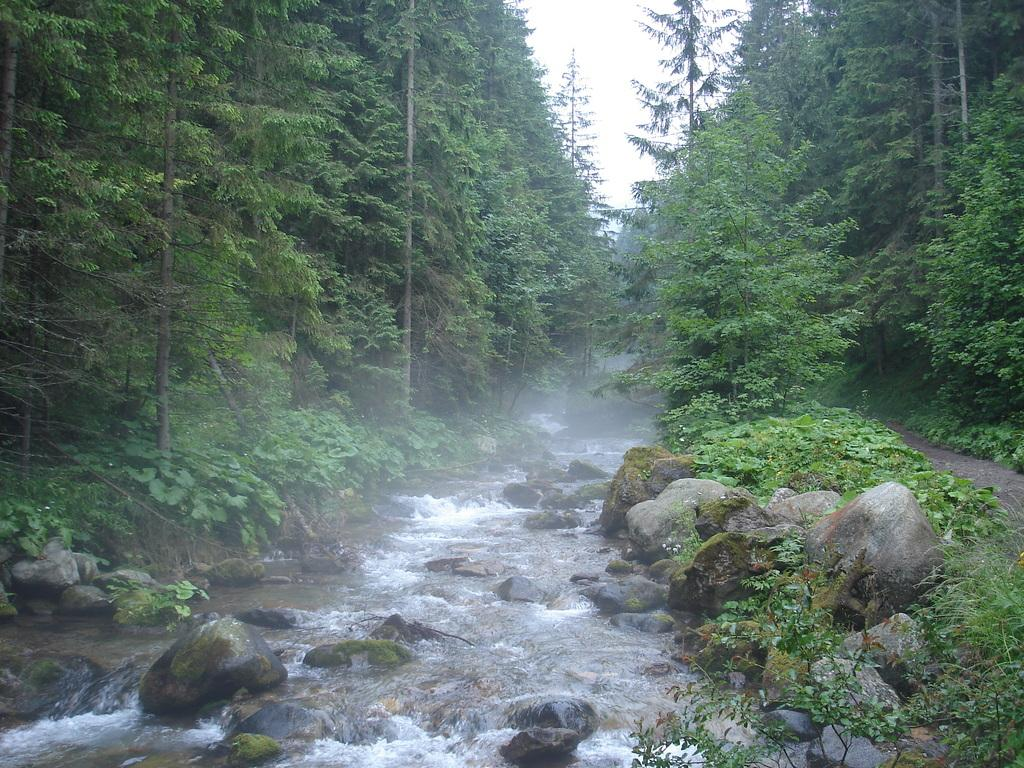What type of natural water feature is present in the image? There is a river in the image. What other geological features can be seen in the image? There are rocks visible in the image. What type of vegetation is present in the image? There are plants and trees in the image. What part of the natural environment is visible in the image? The sky is visible in the image. What type of grain is being served for breakfast in the image? There is no reference to grain or breakfast in the image; it features a river, rocks, plants, trees, and the sky. Can you tell me how many seashores are visible in the image? There is no seashore present in the image; it features a river, rocks, plants, trees, and the sky. 